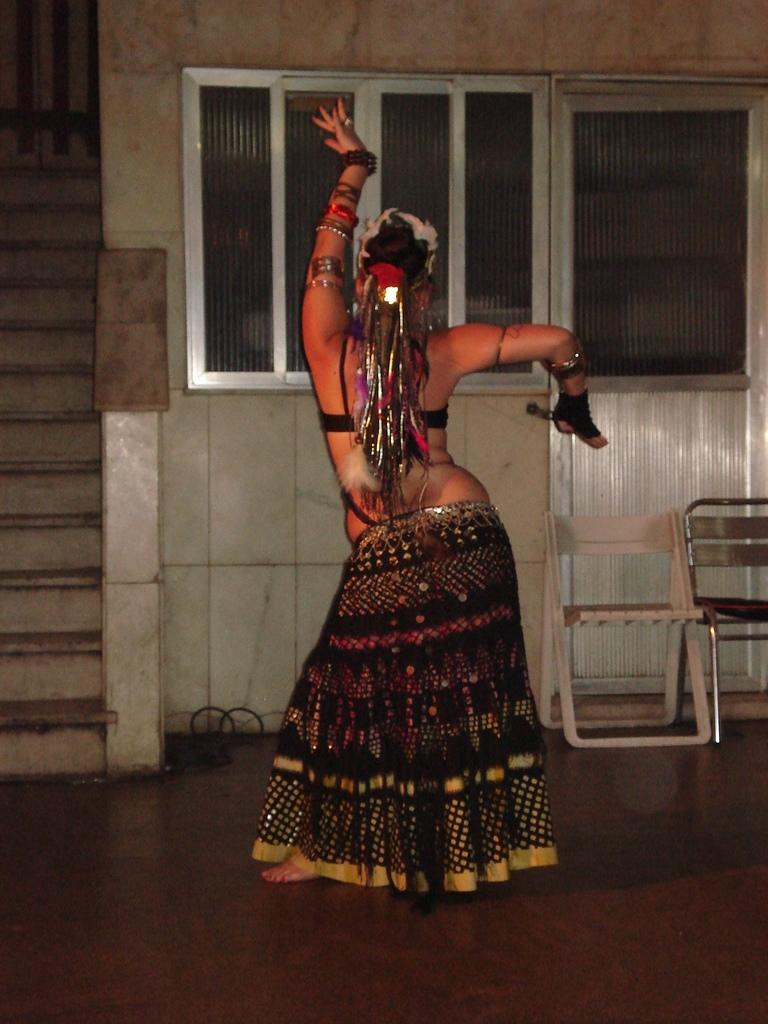Who is the main subject in the image? There is a lady in the image. What is the lady doing in the image? The lady is dancing. What can be seen in the background of the image? There are windows, chairs, and a staircase in the background of the image. What type of action is the spade performing in the image? There is no spade present in the image, so it cannot perform any actions. 